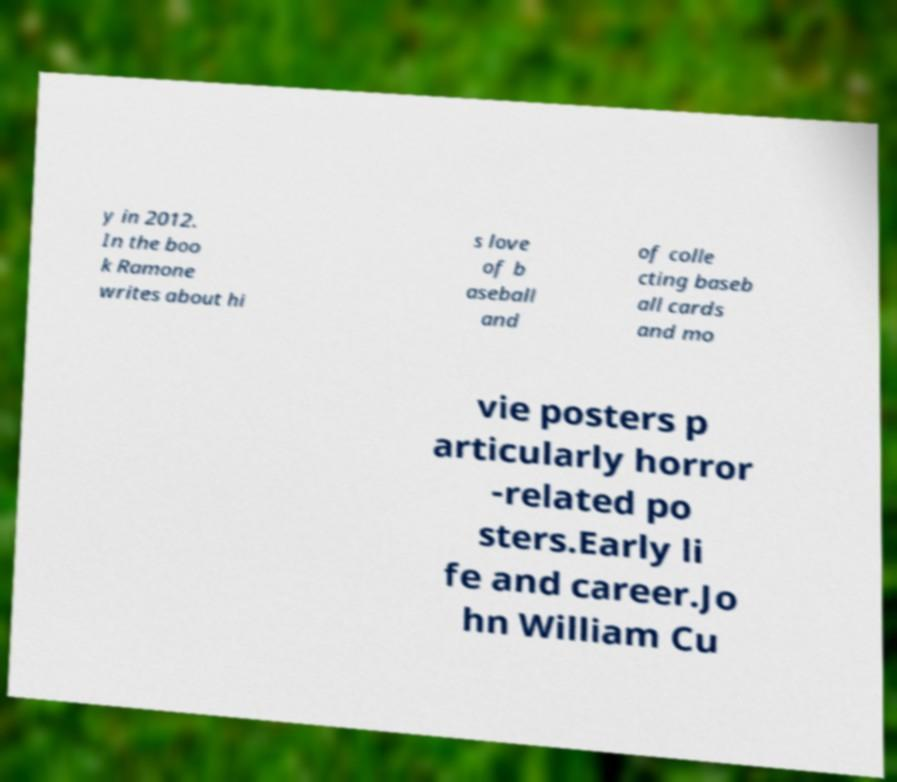Can you accurately transcribe the text from the provided image for me? y in 2012. In the boo k Ramone writes about hi s love of b aseball and of colle cting baseb all cards and mo vie posters p articularly horror -related po sters.Early li fe and career.Jo hn William Cu 